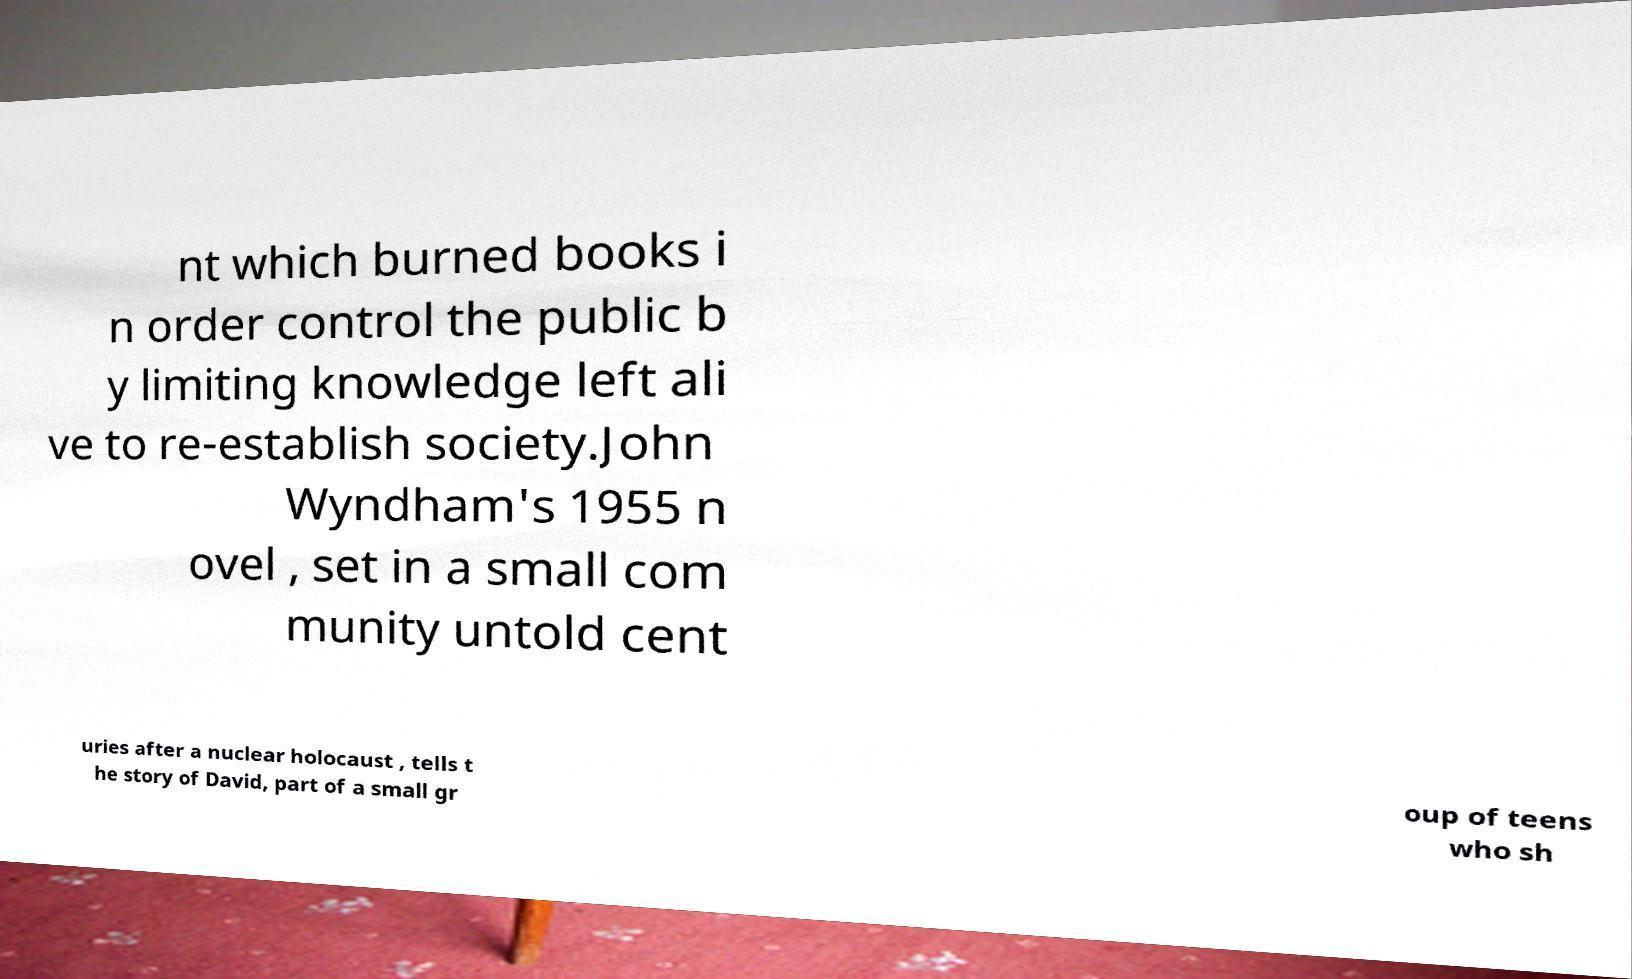There's text embedded in this image that I need extracted. Can you transcribe it verbatim? nt which burned books i n order control the public b y limiting knowledge left ali ve to re-establish society.John Wyndham's 1955 n ovel , set in a small com munity untold cent uries after a nuclear holocaust , tells t he story of David, part of a small gr oup of teens who sh 